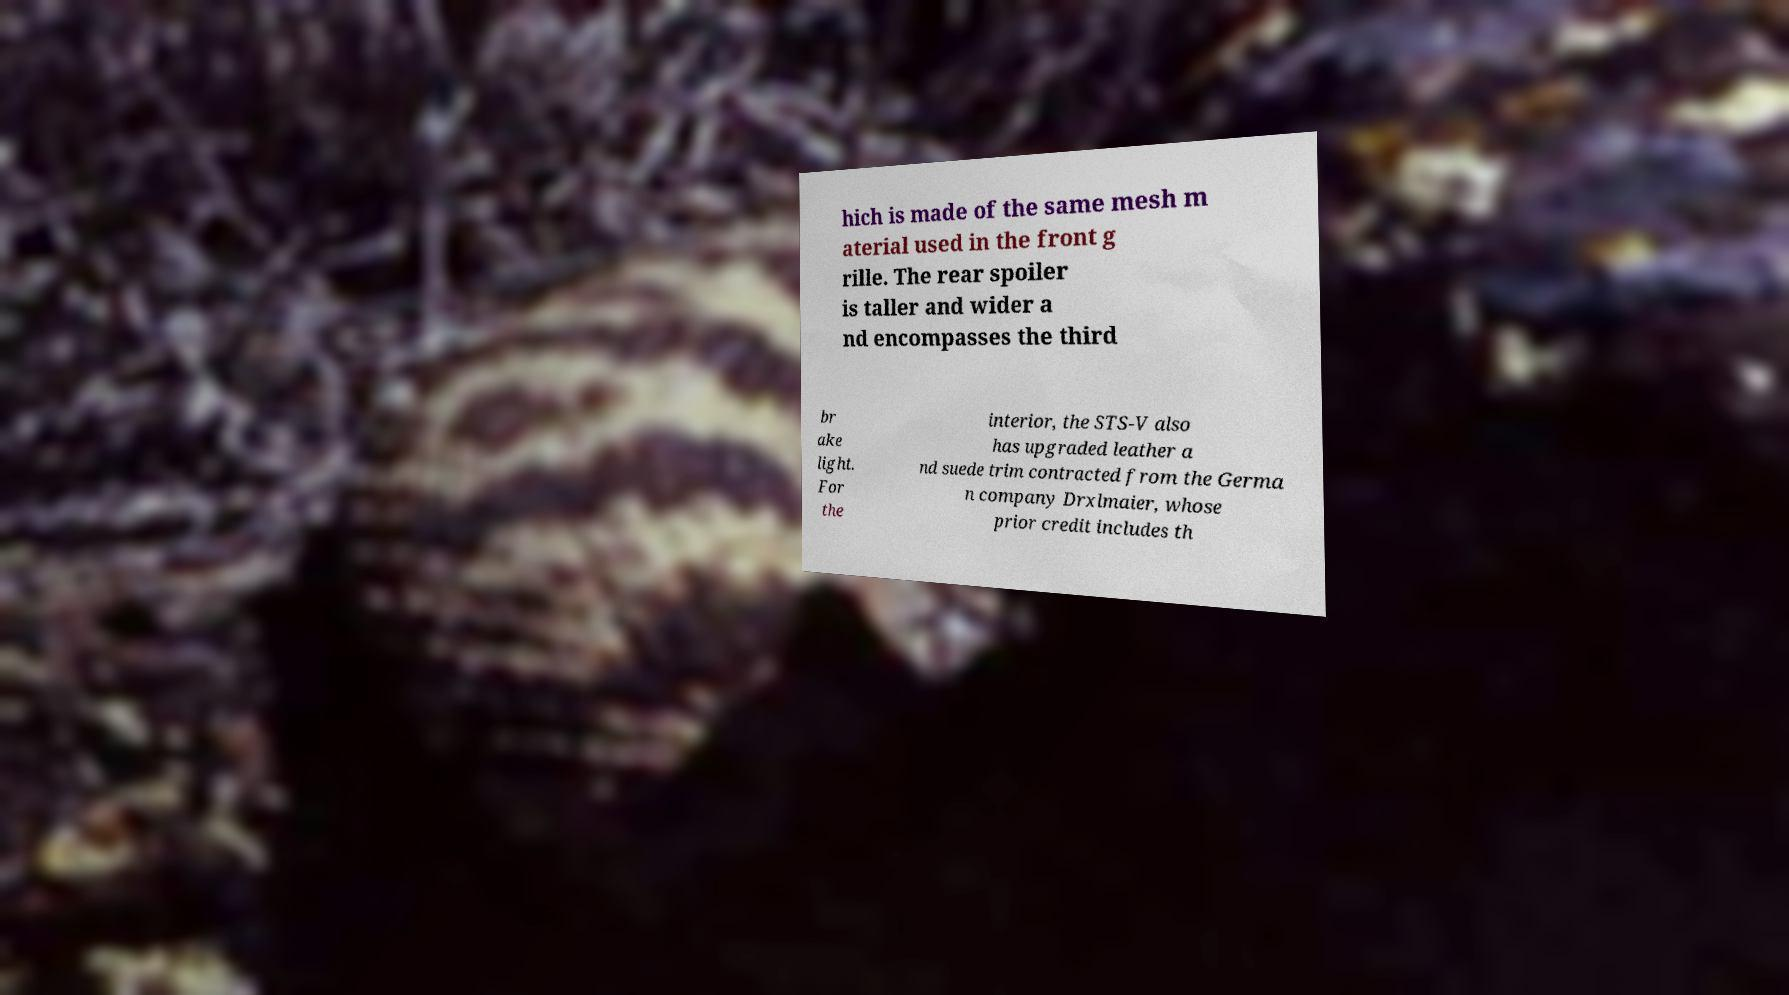Can you read and provide the text displayed in the image?This photo seems to have some interesting text. Can you extract and type it out for me? hich is made of the same mesh m aterial used in the front g rille. The rear spoiler is taller and wider a nd encompasses the third br ake light. For the interior, the STS-V also has upgraded leather a nd suede trim contracted from the Germa n company Drxlmaier, whose prior credit includes th 